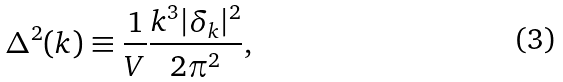Convert formula to latex. <formula><loc_0><loc_0><loc_500><loc_500>\Delta ^ { 2 } ( k ) \equiv \frac { 1 } { V } \frac { k ^ { 3 } | \delta _ { k } | ^ { 2 } } { 2 \pi ^ { 2 } } ,</formula> 